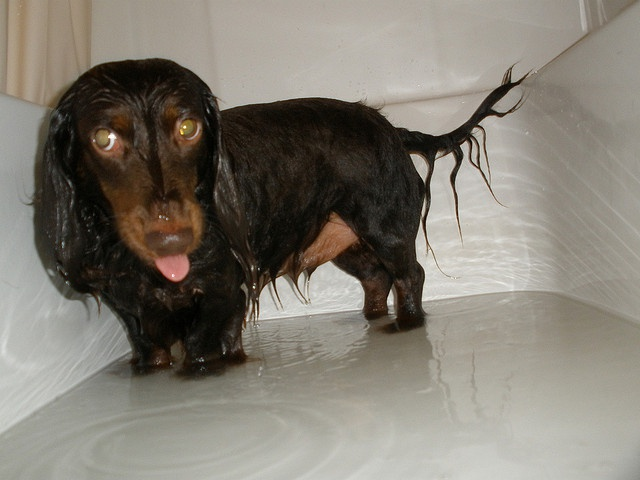Describe the objects in this image and their specific colors. I can see a dog in gray, black, maroon, and darkgray tones in this image. 